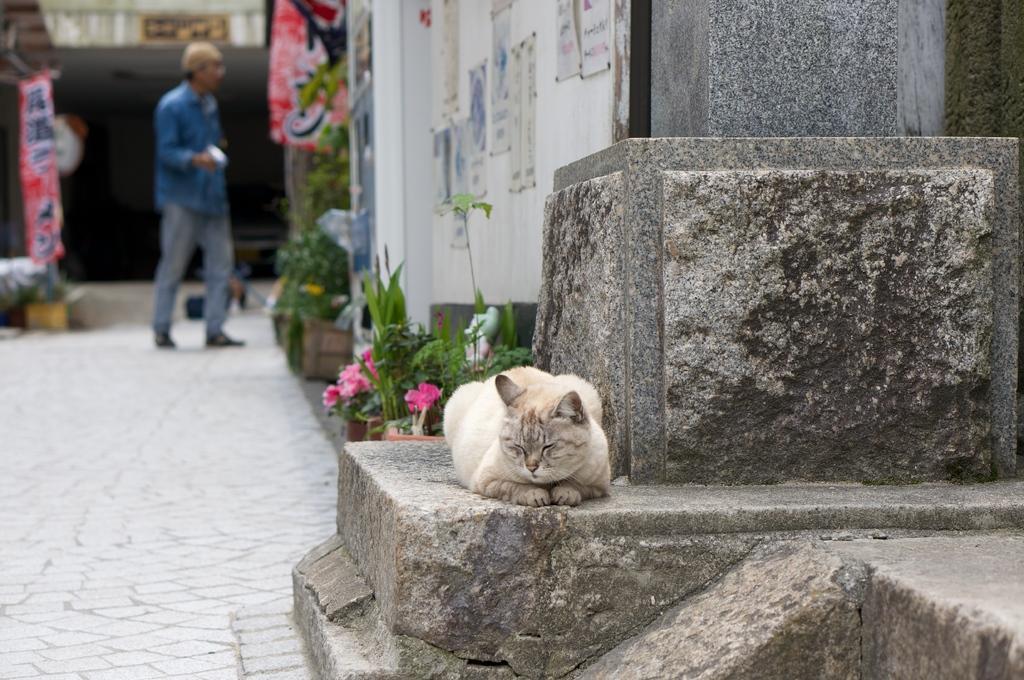How would you summarize this image in a sentence or two? In the foreground of the image we can see a cat laying on the floor. In the background, we can see a person standing on the path, ground of plants, buildings, and some banners. 